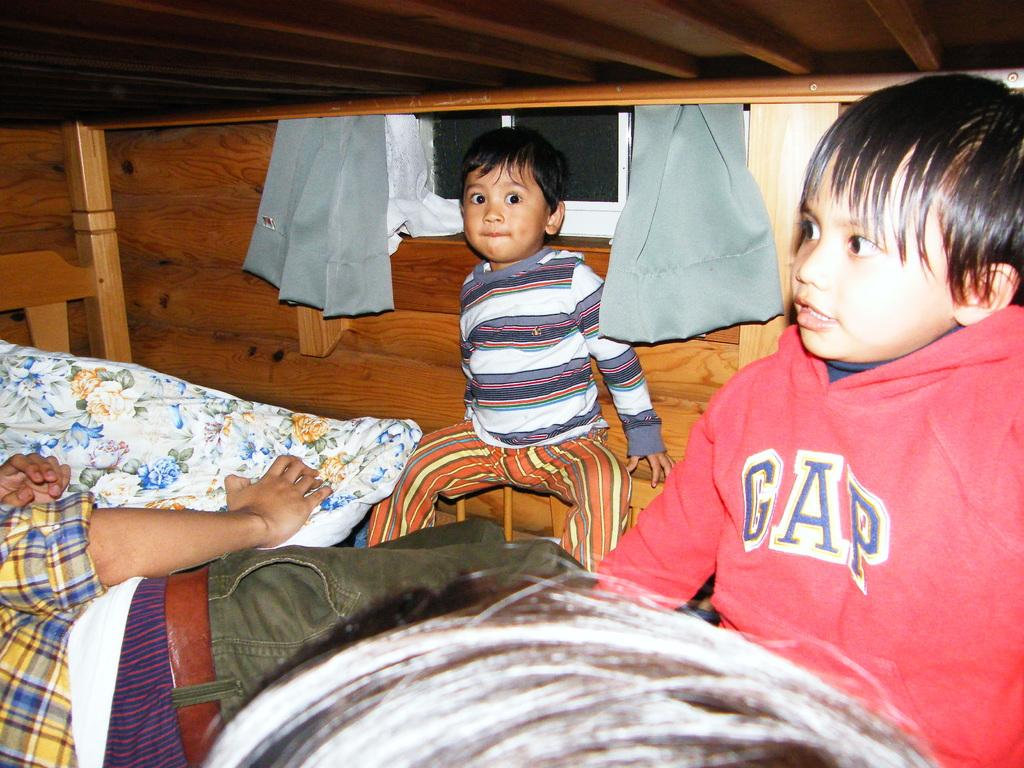What is the person in the image doing? The person is laying on the bed. What is the person holding while laying on the bed? The person is holding a pillow. How many boys are sitting in the image? There are two boys sitting in the image. What can be seen in the background of the image? There is a wooden wall, curtains, and a window in the background. What is the title of the book the person is reading in the image? There is no book present in the image, so there is no title to mention. 